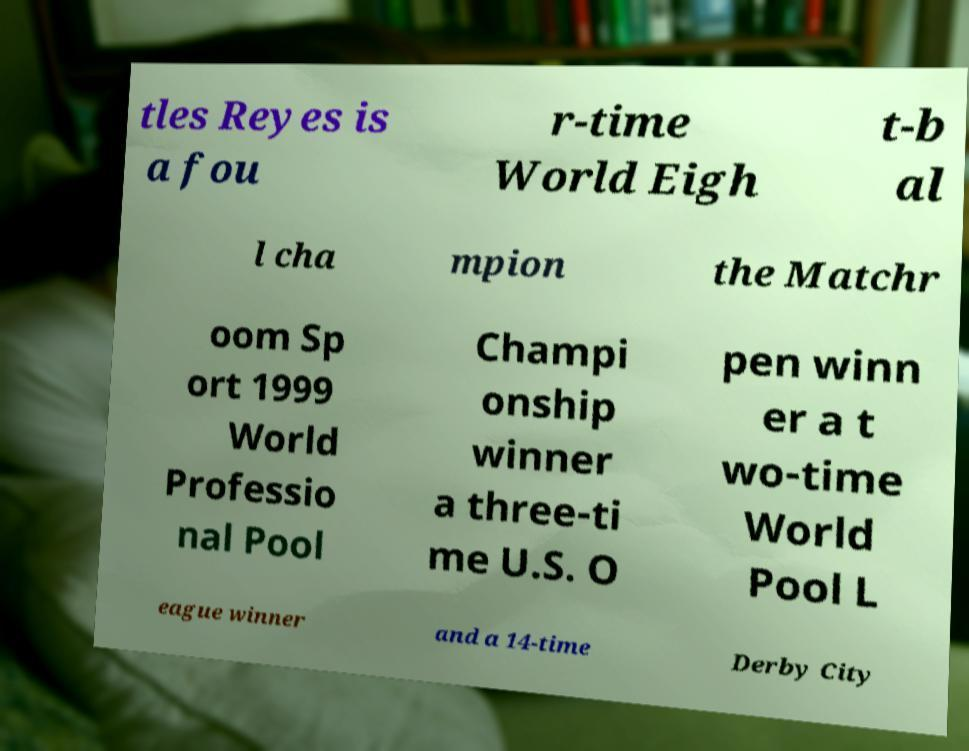I need the written content from this picture converted into text. Can you do that? tles Reyes is a fou r-time World Eigh t-b al l cha mpion the Matchr oom Sp ort 1999 World Professio nal Pool Champi onship winner a three-ti me U.S. O pen winn er a t wo-time World Pool L eague winner and a 14-time Derby City 